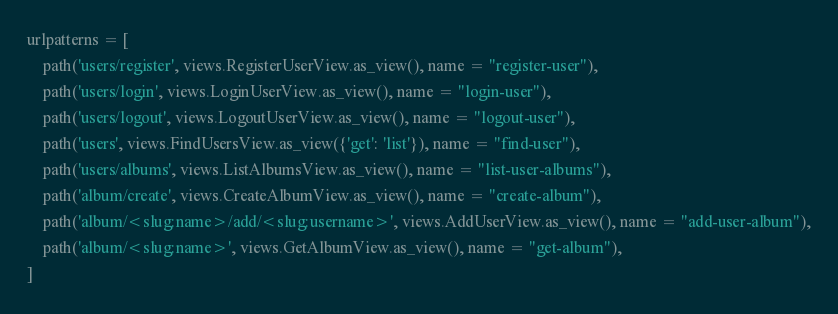<code> <loc_0><loc_0><loc_500><loc_500><_Python_>urlpatterns = [
    path('users/register', views.RegisterUserView.as_view(), name = "register-user"),
    path('users/login', views.LoginUserView.as_view(), name = "login-user"),
    path('users/logout', views.LogoutUserView.as_view(), name = "logout-user"),
    path('users', views.FindUsersView.as_view({'get': 'list'}), name = "find-user"),
    path('users/albums', views.ListAlbumsView.as_view(), name = "list-user-albums"),
    path('album/create', views.CreateAlbumView.as_view(), name = "create-album"),
    path('album/<slug:name>/add/<slug:username>', views.AddUserView.as_view(), name = "add-user-album"),
    path('album/<slug:name>', views.GetAlbumView.as_view(), name = "get-album"),
]
</code> 